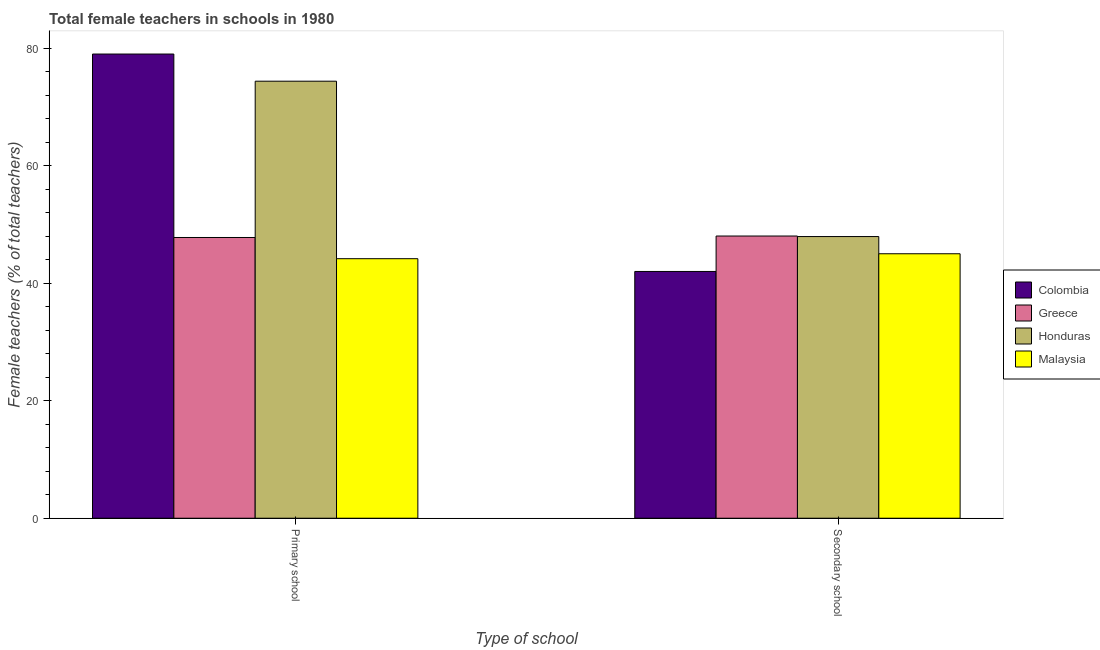How many groups of bars are there?
Your answer should be compact. 2. Are the number of bars per tick equal to the number of legend labels?
Keep it short and to the point. Yes. How many bars are there on the 2nd tick from the right?
Your response must be concise. 4. What is the label of the 2nd group of bars from the left?
Your answer should be compact. Secondary school. What is the percentage of female teachers in secondary schools in Greece?
Ensure brevity in your answer.  48.03. Across all countries, what is the maximum percentage of female teachers in primary schools?
Provide a short and direct response. 79. Across all countries, what is the minimum percentage of female teachers in primary schools?
Give a very brief answer. 44.17. In which country was the percentage of female teachers in secondary schools maximum?
Your response must be concise. Greece. In which country was the percentage of female teachers in primary schools minimum?
Your answer should be very brief. Malaysia. What is the total percentage of female teachers in secondary schools in the graph?
Your response must be concise. 182.98. What is the difference between the percentage of female teachers in primary schools in Honduras and that in Malaysia?
Offer a very short reply. 30.21. What is the difference between the percentage of female teachers in primary schools in Honduras and the percentage of female teachers in secondary schools in Colombia?
Give a very brief answer. 32.38. What is the average percentage of female teachers in secondary schools per country?
Your answer should be very brief. 45.74. What is the difference between the percentage of female teachers in secondary schools and percentage of female teachers in primary schools in Greece?
Keep it short and to the point. 0.25. What is the ratio of the percentage of female teachers in primary schools in Malaysia to that in Colombia?
Your answer should be compact. 0.56. In how many countries, is the percentage of female teachers in primary schools greater than the average percentage of female teachers in primary schools taken over all countries?
Offer a very short reply. 2. What does the 2nd bar from the right in Primary school represents?
Ensure brevity in your answer.  Honduras. How many bars are there?
Provide a succinct answer. 8. Are the values on the major ticks of Y-axis written in scientific E-notation?
Give a very brief answer. No. Where does the legend appear in the graph?
Offer a terse response. Center right. How many legend labels are there?
Offer a very short reply. 4. What is the title of the graph?
Offer a very short reply. Total female teachers in schools in 1980. Does "Least developed countries" appear as one of the legend labels in the graph?
Provide a short and direct response. No. What is the label or title of the X-axis?
Your response must be concise. Type of school. What is the label or title of the Y-axis?
Your answer should be compact. Female teachers (% of total teachers). What is the Female teachers (% of total teachers) in Colombia in Primary school?
Your response must be concise. 79. What is the Female teachers (% of total teachers) of Greece in Primary school?
Make the answer very short. 47.78. What is the Female teachers (% of total teachers) of Honduras in Primary school?
Offer a very short reply. 74.38. What is the Female teachers (% of total teachers) of Malaysia in Primary school?
Provide a short and direct response. 44.17. What is the Female teachers (% of total teachers) in Colombia in Secondary school?
Give a very brief answer. 42. What is the Female teachers (% of total teachers) of Greece in Secondary school?
Give a very brief answer. 48.03. What is the Female teachers (% of total teachers) of Honduras in Secondary school?
Make the answer very short. 47.94. What is the Female teachers (% of total teachers) of Malaysia in Secondary school?
Provide a succinct answer. 45.01. Across all Type of school, what is the maximum Female teachers (% of total teachers) of Colombia?
Your answer should be compact. 79. Across all Type of school, what is the maximum Female teachers (% of total teachers) in Greece?
Your answer should be compact. 48.03. Across all Type of school, what is the maximum Female teachers (% of total teachers) of Honduras?
Give a very brief answer. 74.38. Across all Type of school, what is the maximum Female teachers (% of total teachers) in Malaysia?
Offer a terse response. 45.01. Across all Type of school, what is the minimum Female teachers (% of total teachers) of Colombia?
Offer a very short reply. 42. Across all Type of school, what is the minimum Female teachers (% of total teachers) in Greece?
Make the answer very short. 47.78. Across all Type of school, what is the minimum Female teachers (% of total teachers) in Honduras?
Your answer should be very brief. 47.94. Across all Type of school, what is the minimum Female teachers (% of total teachers) in Malaysia?
Provide a short and direct response. 44.17. What is the total Female teachers (% of total teachers) in Colombia in the graph?
Provide a succinct answer. 121. What is the total Female teachers (% of total teachers) in Greece in the graph?
Your response must be concise. 95.81. What is the total Female teachers (% of total teachers) of Honduras in the graph?
Make the answer very short. 122.32. What is the total Female teachers (% of total teachers) of Malaysia in the graph?
Your answer should be very brief. 89.18. What is the difference between the Female teachers (% of total teachers) in Colombia in Primary school and that in Secondary school?
Ensure brevity in your answer.  37. What is the difference between the Female teachers (% of total teachers) in Greece in Primary school and that in Secondary school?
Provide a short and direct response. -0.25. What is the difference between the Female teachers (% of total teachers) in Honduras in Primary school and that in Secondary school?
Give a very brief answer. 26.44. What is the difference between the Female teachers (% of total teachers) in Malaysia in Primary school and that in Secondary school?
Keep it short and to the point. -0.84. What is the difference between the Female teachers (% of total teachers) of Colombia in Primary school and the Female teachers (% of total teachers) of Greece in Secondary school?
Offer a very short reply. 30.97. What is the difference between the Female teachers (% of total teachers) in Colombia in Primary school and the Female teachers (% of total teachers) in Honduras in Secondary school?
Keep it short and to the point. 31.06. What is the difference between the Female teachers (% of total teachers) in Colombia in Primary school and the Female teachers (% of total teachers) in Malaysia in Secondary school?
Provide a succinct answer. 33.99. What is the difference between the Female teachers (% of total teachers) in Greece in Primary school and the Female teachers (% of total teachers) in Honduras in Secondary school?
Provide a succinct answer. -0.16. What is the difference between the Female teachers (% of total teachers) of Greece in Primary school and the Female teachers (% of total teachers) of Malaysia in Secondary school?
Your response must be concise. 2.77. What is the difference between the Female teachers (% of total teachers) of Honduras in Primary school and the Female teachers (% of total teachers) of Malaysia in Secondary school?
Ensure brevity in your answer.  29.37. What is the average Female teachers (% of total teachers) of Colombia per Type of school?
Make the answer very short. 60.5. What is the average Female teachers (% of total teachers) of Greece per Type of school?
Make the answer very short. 47.9. What is the average Female teachers (% of total teachers) in Honduras per Type of school?
Ensure brevity in your answer.  61.16. What is the average Female teachers (% of total teachers) in Malaysia per Type of school?
Offer a terse response. 44.59. What is the difference between the Female teachers (% of total teachers) in Colombia and Female teachers (% of total teachers) in Greece in Primary school?
Your answer should be compact. 31.22. What is the difference between the Female teachers (% of total teachers) in Colombia and Female teachers (% of total teachers) in Honduras in Primary school?
Your answer should be compact. 4.62. What is the difference between the Female teachers (% of total teachers) in Colombia and Female teachers (% of total teachers) in Malaysia in Primary school?
Provide a short and direct response. 34.83. What is the difference between the Female teachers (% of total teachers) in Greece and Female teachers (% of total teachers) in Honduras in Primary school?
Provide a succinct answer. -26.6. What is the difference between the Female teachers (% of total teachers) in Greece and Female teachers (% of total teachers) in Malaysia in Primary school?
Keep it short and to the point. 3.61. What is the difference between the Female teachers (% of total teachers) in Honduras and Female teachers (% of total teachers) in Malaysia in Primary school?
Provide a succinct answer. 30.21. What is the difference between the Female teachers (% of total teachers) of Colombia and Female teachers (% of total teachers) of Greece in Secondary school?
Your response must be concise. -6.03. What is the difference between the Female teachers (% of total teachers) in Colombia and Female teachers (% of total teachers) in Honduras in Secondary school?
Provide a short and direct response. -5.94. What is the difference between the Female teachers (% of total teachers) of Colombia and Female teachers (% of total teachers) of Malaysia in Secondary school?
Your response must be concise. -3.01. What is the difference between the Female teachers (% of total teachers) in Greece and Female teachers (% of total teachers) in Honduras in Secondary school?
Your response must be concise. 0.09. What is the difference between the Female teachers (% of total teachers) in Greece and Female teachers (% of total teachers) in Malaysia in Secondary school?
Offer a terse response. 3.02. What is the difference between the Female teachers (% of total teachers) of Honduras and Female teachers (% of total teachers) of Malaysia in Secondary school?
Provide a succinct answer. 2.93. What is the ratio of the Female teachers (% of total teachers) in Colombia in Primary school to that in Secondary school?
Provide a succinct answer. 1.88. What is the ratio of the Female teachers (% of total teachers) in Honduras in Primary school to that in Secondary school?
Offer a terse response. 1.55. What is the ratio of the Female teachers (% of total teachers) in Malaysia in Primary school to that in Secondary school?
Provide a short and direct response. 0.98. What is the difference between the highest and the second highest Female teachers (% of total teachers) in Colombia?
Offer a terse response. 37. What is the difference between the highest and the second highest Female teachers (% of total teachers) in Greece?
Make the answer very short. 0.25. What is the difference between the highest and the second highest Female teachers (% of total teachers) in Honduras?
Your answer should be very brief. 26.44. What is the difference between the highest and the second highest Female teachers (% of total teachers) of Malaysia?
Make the answer very short. 0.84. What is the difference between the highest and the lowest Female teachers (% of total teachers) of Colombia?
Ensure brevity in your answer.  37. What is the difference between the highest and the lowest Female teachers (% of total teachers) in Greece?
Your response must be concise. 0.25. What is the difference between the highest and the lowest Female teachers (% of total teachers) in Honduras?
Your answer should be very brief. 26.44. What is the difference between the highest and the lowest Female teachers (% of total teachers) in Malaysia?
Your response must be concise. 0.84. 